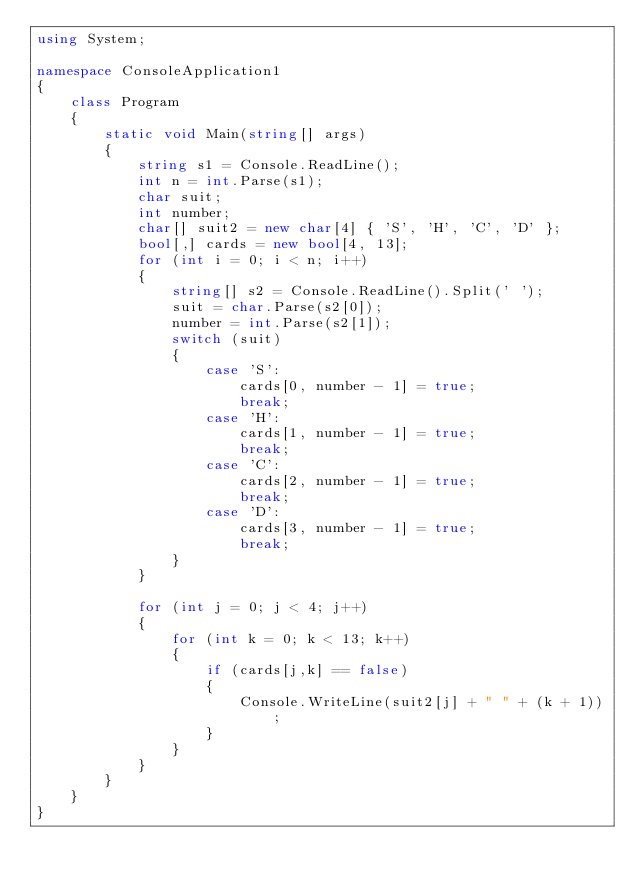<code> <loc_0><loc_0><loc_500><loc_500><_C#_>using System;

namespace ConsoleApplication1
{
    class Program
    {
        static void Main(string[] args)
        {
            string s1 = Console.ReadLine();
            int n = int.Parse(s1);
            char suit;
            int number;
            char[] suit2 = new char[4] { 'S', 'H', 'C', 'D' };
            bool[,] cards = new bool[4, 13];
            for (int i = 0; i < n; i++)
            {
                string[] s2 = Console.ReadLine().Split(' ');
                suit = char.Parse(s2[0]);
                number = int.Parse(s2[1]);
                switch (suit)
                {
                    case 'S':
                        cards[0, number - 1] = true;
                        break;
                    case 'H':
                        cards[1, number - 1] = true;
                        break;
                    case 'C':
                        cards[2, number - 1] = true;
                        break;
                    case 'D':
                        cards[3, number - 1] = true;
                        break;
                }
            }

            for (int j = 0; j < 4; j++)
            {
                for (int k = 0; k < 13; k++)
                {
                    if (cards[j,k] == false)
                    {
                        Console.WriteLine(suit2[j] + " " + (k + 1));
                    }
                }
            }
        }
    }
}</code> 